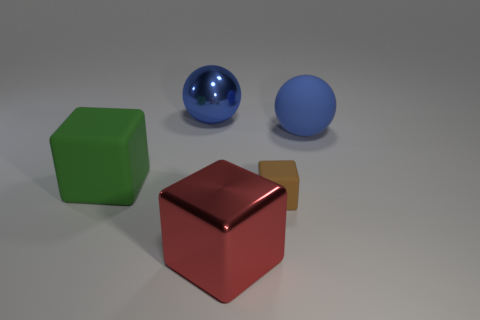There is a rubber block that is in front of the green rubber block; is it the same size as the big shiny ball?
Provide a succinct answer. No. What number of objects are large blocks or small green metal cylinders?
Keep it short and to the point. 2. The object that is the same color as the matte ball is what shape?
Provide a short and direct response. Sphere. There is a cube that is on the left side of the tiny rubber block and in front of the green thing; what size is it?
Your answer should be compact. Large. What number of cyan cubes are there?
Keep it short and to the point. 0. What number of spheres are blue rubber objects or metallic objects?
Your answer should be very brief. 2. How many big red metal objects are behind the large green object that is to the left of the blue thing to the left of the tiny rubber object?
Offer a terse response. 0. What is the color of the rubber cube that is the same size as the rubber sphere?
Make the answer very short. Green. What number of other things are there of the same color as the tiny matte thing?
Offer a terse response. 0. Are there more blue matte things that are left of the large blue matte thing than large gray metallic things?
Provide a short and direct response. No. 